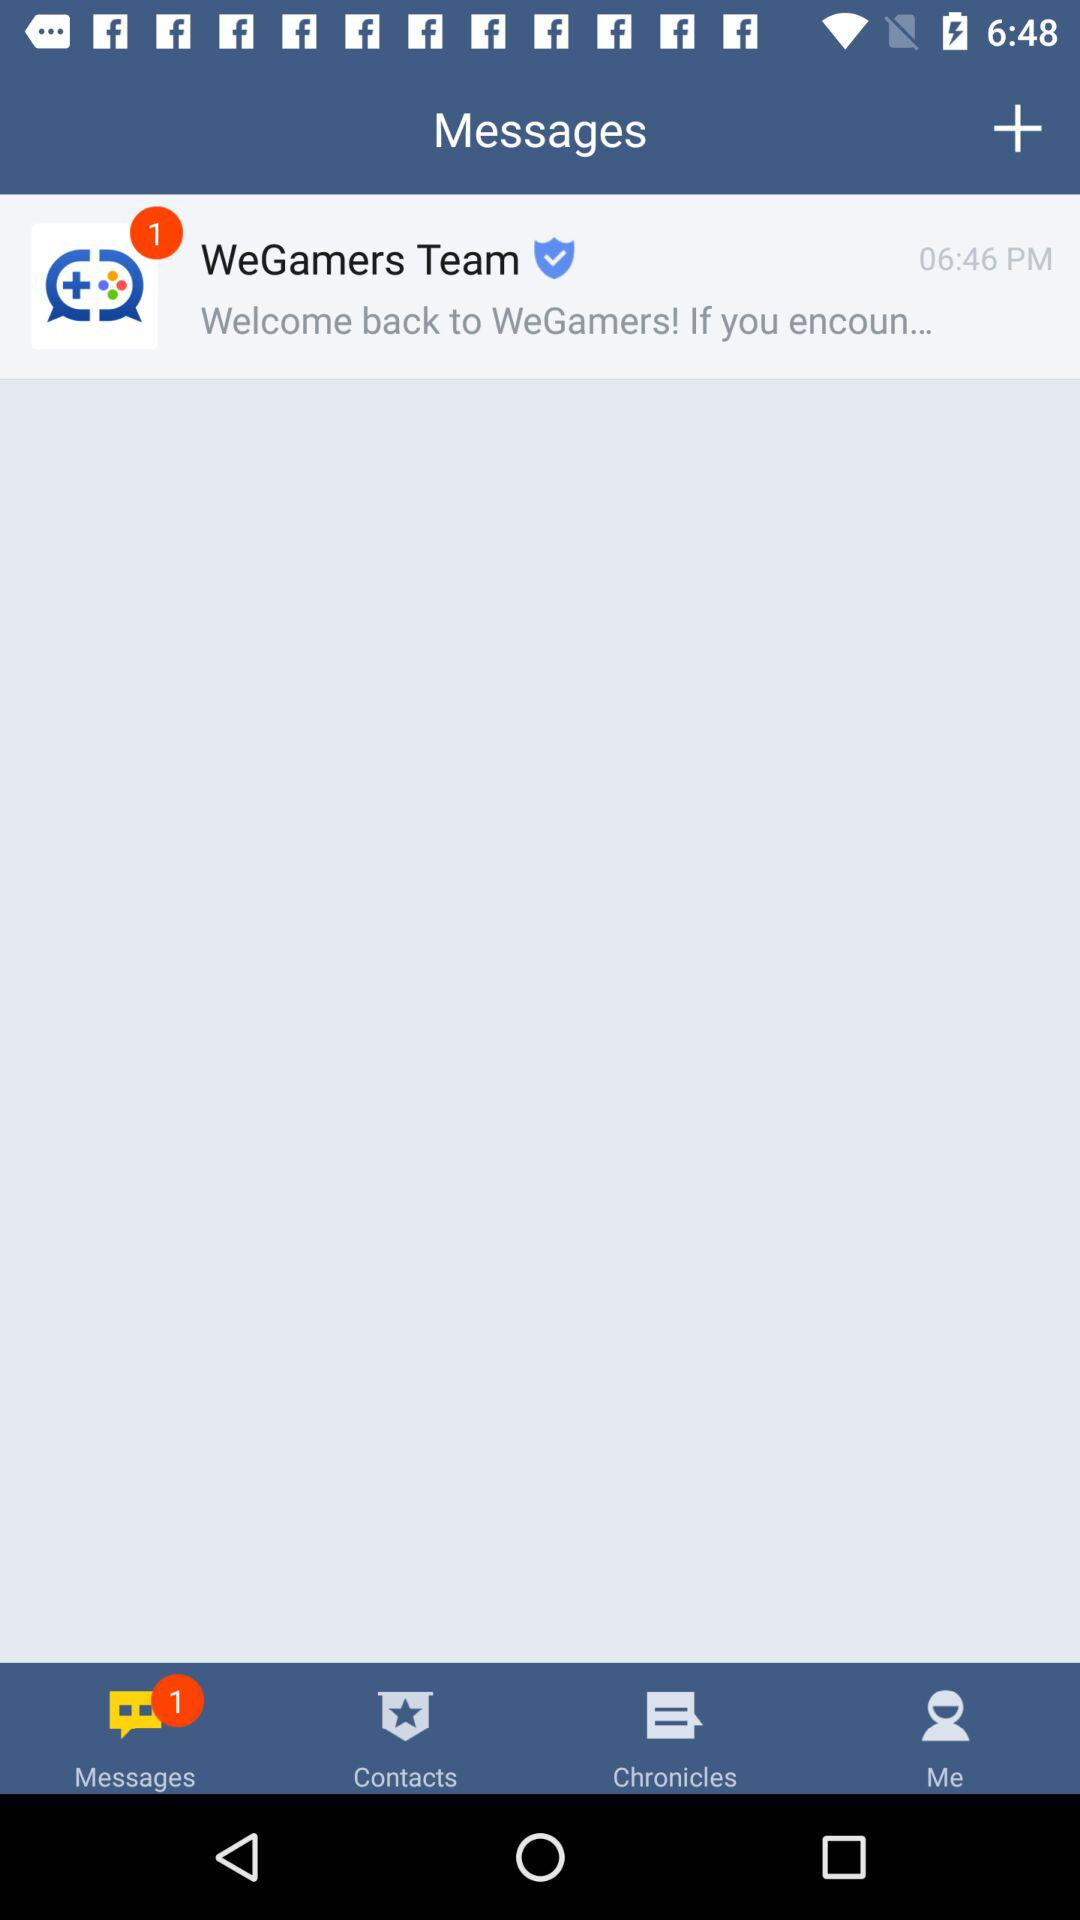How many messages do I have?
Answer the question using a single word or phrase. 1 